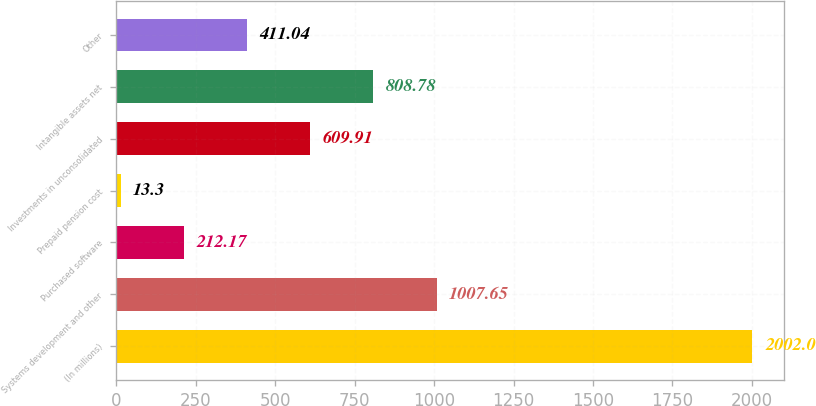Convert chart. <chart><loc_0><loc_0><loc_500><loc_500><bar_chart><fcel>(In millions)<fcel>Systems development and other<fcel>Purchased software<fcel>Prepaid pension cost<fcel>Investments in unconsolidated<fcel>Intangible assets net<fcel>Other<nl><fcel>2002<fcel>1007.65<fcel>212.17<fcel>13.3<fcel>609.91<fcel>808.78<fcel>411.04<nl></chart> 